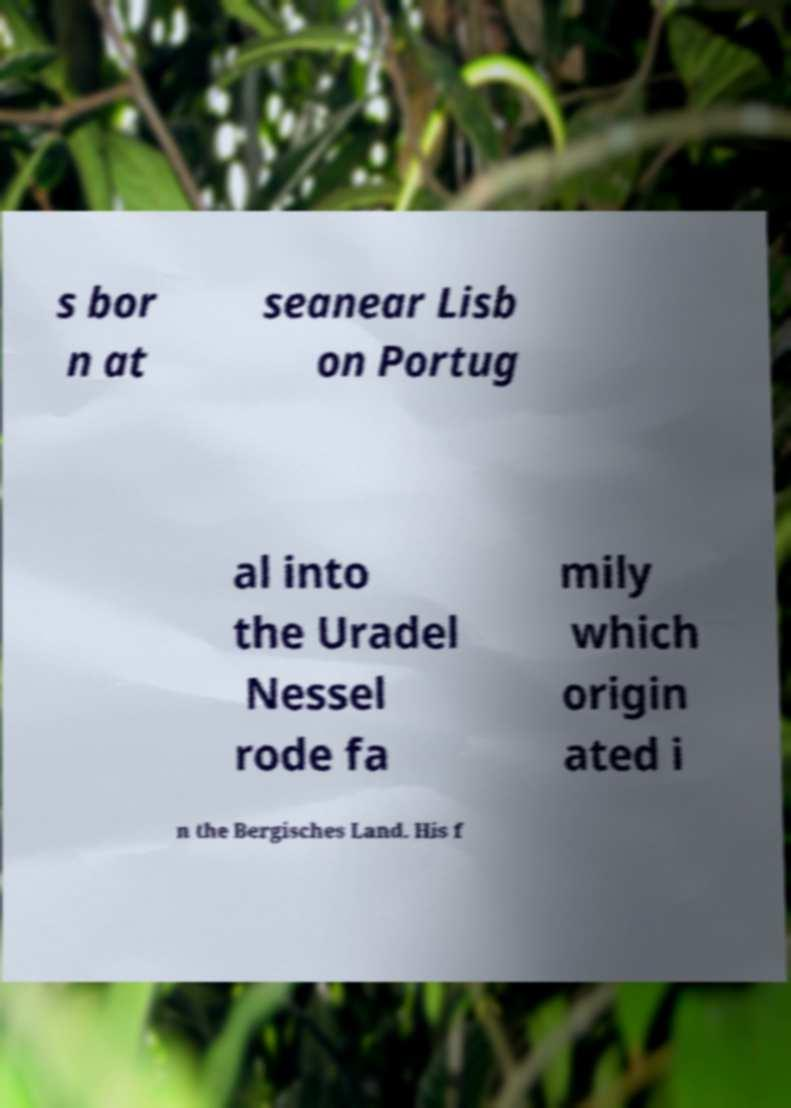Could you extract and type out the text from this image? s bor n at seanear Lisb on Portug al into the Uradel Nessel rode fa mily which origin ated i n the Bergisches Land. His f 